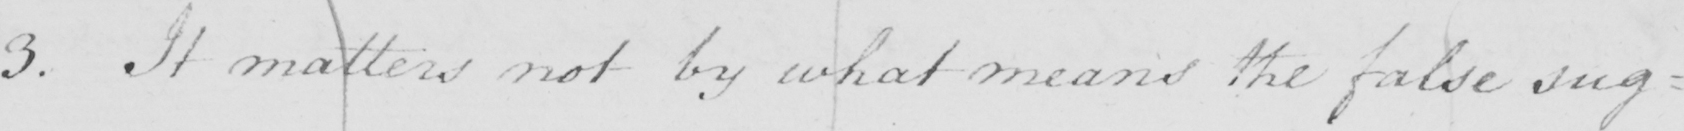What is written in this line of handwriting? 3 . It matters not by what means the false sug= 